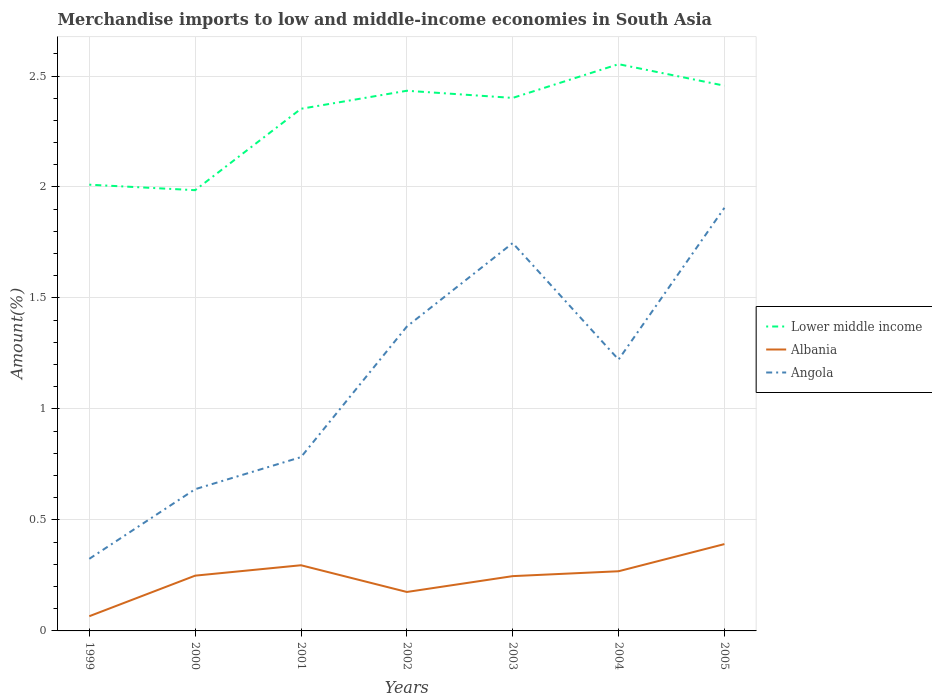Is the number of lines equal to the number of legend labels?
Offer a very short reply. Yes. Across all years, what is the maximum percentage of amount earned from merchandise imports in Angola?
Keep it short and to the point. 0.32. In which year was the percentage of amount earned from merchandise imports in Albania maximum?
Make the answer very short. 1999. What is the total percentage of amount earned from merchandise imports in Lower middle income in the graph?
Offer a terse response. -0.34. What is the difference between the highest and the second highest percentage of amount earned from merchandise imports in Albania?
Give a very brief answer. 0.32. How many lines are there?
Your response must be concise. 3. How many years are there in the graph?
Provide a short and direct response. 7. What is the difference between two consecutive major ticks on the Y-axis?
Your answer should be compact. 0.5. Are the values on the major ticks of Y-axis written in scientific E-notation?
Your answer should be compact. No. Does the graph contain any zero values?
Your answer should be very brief. No. How are the legend labels stacked?
Provide a short and direct response. Vertical. What is the title of the graph?
Your response must be concise. Merchandise imports to low and middle-income economies in South Asia. Does "Belarus" appear as one of the legend labels in the graph?
Make the answer very short. No. What is the label or title of the X-axis?
Offer a very short reply. Years. What is the label or title of the Y-axis?
Your answer should be very brief. Amount(%). What is the Amount(%) of Lower middle income in 1999?
Give a very brief answer. 2.01. What is the Amount(%) of Albania in 1999?
Make the answer very short. 0.07. What is the Amount(%) of Angola in 1999?
Provide a succinct answer. 0.32. What is the Amount(%) of Lower middle income in 2000?
Your answer should be very brief. 1.99. What is the Amount(%) of Albania in 2000?
Offer a very short reply. 0.25. What is the Amount(%) of Angola in 2000?
Make the answer very short. 0.64. What is the Amount(%) of Lower middle income in 2001?
Your answer should be very brief. 2.35. What is the Amount(%) of Albania in 2001?
Offer a very short reply. 0.3. What is the Amount(%) in Angola in 2001?
Keep it short and to the point. 0.78. What is the Amount(%) in Lower middle income in 2002?
Offer a terse response. 2.43. What is the Amount(%) in Albania in 2002?
Provide a short and direct response. 0.18. What is the Amount(%) of Angola in 2002?
Your response must be concise. 1.37. What is the Amount(%) in Lower middle income in 2003?
Provide a short and direct response. 2.4. What is the Amount(%) of Albania in 2003?
Offer a terse response. 0.25. What is the Amount(%) of Angola in 2003?
Offer a very short reply. 1.75. What is the Amount(%) in Lower middle income in 2004?
Provide a succinct answer. 2.55. What is the Amount(%) of Albania in 2004?
Offer a very short reply. 0.27. What is the Amount(%) of Angola in 2004?
Offer a terse response. 1.22. What is the Amount(%) of Lower middle income in 2005?
Keep it short and to the point. 2.46. What is the Amount(%) of Albania in 2005?
Offer a terse response. 0.39. What is the Amount(%) of Angola in 2005?
Offer a very short reply. 1.91. Across all years, what is the maximum Amount(%) in Lower middle income?
Provide a succinct answer. 2.55. Across all years, what is the maximum Amount(%) in Albania?
Provide a short and direct response. 0.39. Across all years, what is the maximum Amount(%) in Angola?
Keep it short and to the point. 1.91. Across all years, what is the minimum Amount(%) of Lower middle income?
Your response must be concise. 1.99. Across all years, what is the minimum Amount(%) in Albania?
Give a very brief answer. 0.07. Across all years, what is the minimum Amount(%) in Angola?
Keep it short and to the point. 0.32. What is the total Amount(%) in Lower middle income in the graph?
Keep it short and to the point. 16.19. What is the total Amount(%) in Albania in the graph?
Offer a very short reply. 1.69. What is the total Amount(%) in Angola in the graph?
Provide a short and direct response. 7.99. What is the difference between the Amount(%) of Lower middle income in 1999 and that in 2000?
Your answer should be compact. 0.02. What is the difference between the Amount(%) of Albania in 1999 and that in 2000?
Offer a very short reply. -0.18. What is the difference between the Amount(%) in Angola in 1999 and that in 2000?
Your response must be concise. -0.31. What is the difference between the Amount(%) of Lower middle income in 1999 and that in 2001?
Provide a succinct answer. -0.34. What is the difference between the Amount(%) of Albania in 1999 and that in 2001?
Make the answer very short. -0.23. What is the difference between the Amount(%) in Angola in 1999 and that in 2001?
Provide a short and direct response. -0.46. What is the difference between the Amount(%) of Lower middle income in 1999 and that in 2002?
Give a very brief answer. -0.42. What is the difference between the Amount(%) of Albania in 1999 and that in 2002?
Your answer should be compact. -0.11. What is the difference between the Amount(%) of Angola in 1999 and that in 2002?
Your response must be concise. -1.05. What is the difference between the Amount(%) of Lower middle income in 1999 and that in 2003?
Make the answer very short. -0.39. What is the difference between the Amount(%) in Albania in 1999 and that in 2003?
Offer a very short reply. -0.18. What is the difference between the Amount(%) in Angola in 1999 and that in 2003?
Ensure brevity in your answer.  -1.42. What is the difference between the Amount(%) of Lower middle income in 1999 and that in 2004?
Make the answer very short. -0.54. What is the difference between the Amount(%) in Albania in 1999 and that in 2004?
Make the answer very short. -0.2. What is the difference between the Amount(%) in Angola in 1999 and that in 2004?
Your answer should be very brief. -0.9. What is the difference between the Amount(%) of Lower middle income in 1999 and that in 2005?
Keep it short and to the point. -0.45. What is the difference between the Amount(%) of Albania in 1999 and that in 2005?
Give a very brief answer. -0.33. What is the difference between the Amount(%) of Angola in 1999 and that in 2005?
Offer a very short reply. -1.58. What is the difference between the Amount(%) in Lower middle income in 2000 and that in 2001?
Offer a terse response. -0.37. What is the difference between the Amount(%) of Albania in 2000 and that in 2001?
Make the answer very short. -0.05. What is the difference between the Amount(%) in Angola in 2000 and that in 2001?
Make the answer very short. -0.14. What is the difference between the Amount(%) in Lower middle income in 2000 and that in 2002?
Ensure brevity in your answer.  -0.45. What is the difference between the Amount(%) of Albania in 2000 and that in 2002?
Offer a terse response. 0.07. What is the difference between the Amount(%) of Angola in 2000 and that in 2002?
Keep it short and to the point. -0.73. What is the difference between the Amount(%) of Lower middle income in 2000 and that in 2003?
Ensure brevity in your answer.  -0.42. What is the difference between the Amount(%) of Albania in 2000 and that in 2003?
Your response must be concise. 0. What is the difference between the Amount(%) of Angola in 2000 and that in 2003?
Your response must be concise. -1.11. What is the difference between the Amount(%) in Lower middle income in 2000 and that in 2004?
Provide a succinct answer. -0.57. What is the difference between the Amount(%) of Albania in 2000 and that in 2004?
Give a very brief answer. -0.02. What is the difference between the Amount(%) in Angola in 2000 and that in 2004?
Offer a very short reply. -0.58. What is the difference between the Amount(%) in Lower middle income in 2000 and that in 2005?
Offer a very short reply. -0.47. What is the difference between the Amount(%) of Albania in 2000 and that in 2005?
Provide a short and direct response. -0.14. What is the difference between the Amount(%) of Angola in 2000 and that in 2005?
Ensure brevity in your answer.  -1.27. What is the difference between the Amount(%) in Lower middle income in 2001 and that in 2002?
Your response must be concise. -0.08. What is the difference between the Amount(%) of Albania in 2001 and that in 2002?
Give a very brief answer. 0.12. What is the difference between the Amount(%) of Angola in 2001 and that in 2002?
Provide a short and direct response. -0.59. What is the difference between the Amount(%) in Lower middle income in 2001 and that in 2003?
Offer a very short reply. -0.05. What is the difference between the Amount(%) in Albania in 2001 and that in 2003?
Your answer should be compact. 0.05. What is the difference between the Amount(%) in Angola in 2001 and that in 2003?
Keep it short and to the point. -0.96. What is the difference between the Amount(%) of Lower middle income in 2001 and that in 2004?
Your answer should be very brief. -0.2. What is the difference between the Amount(%) of Albania in 2001 and that in 2004?
Offer a very short reply. 0.03. What is the difference between the Amount(%) in Angola in 2001 and that in 2004?
Ensure brevity in your answer.  -0.44. What is the difference between the Amount(%) in Lower middle income in 2001 and that in 2005?
Give a very brief answer. -0.1. What is the difference between the Amount(%) of Albania in 2001 and that in 2005?
Your answer should be compact. -0.1. What is the difference between the Amount(%) of Angola in 2001 and that in 2005?
Your answer should be very brief. -1.12. What is the difference between the Amount(%) in Lower middle income in 2002 and that in 2003?
Your answer should be compact. 0.03. What is the difference between the Amount(%) of Albania in 2002 and that in 2003?
Provide a succinct answer. -0.07. What is the difference between the Amount(%) of Angola in 2002 and that in 2003?
Offer a very short reply. -0.38. What is the difference between the Amount(%) in Lower middle income in 2002 and that in 2004?
Your answer should be very brief. -0.12. What is the difference between the Amount(%) in Albania in 2002 and that in 2004?
Your answer should be compact. -0.09. What is the difference between the Amount(%) in Angola in 2002 and that in 2004?
Provide a short and direct response. 0.15. What is the difference between the Amount(%) in Lower middle income in 2002 and that in 2005?
Your answer should be compact. -0.02. What is the difference between the Amount(%) in Albania in 2002 and that in 2005?
Keep it short and to the point. -0.22. What is the difference between the Amount(%) in Angola in 2002 and that in 2005?
Give a very brief answer. -0.53. What is the difference between the Amount(%) of Lower middle income in 2003 and that in 2004?
Provide a short and direct response. -0.15. What is the difference between the Amount(%) in Albania in 2003 and that in 2004?
Offer a very short reply. -0.02. What is the difference between the Amount(%) of Angola in 2003 and that in 2004?
Make the answer very short. 0.52. What is the difference between the Amount(%) of Lower middle income in 2003 and that in 2005?
Ensure brevity in your answer.  -0.06. What is the difference between the Amount(%) in Albania in 2003 and that in 2005?
Keep it short and to the point. -0.14. What is the difference between the Amount(%) of Angola in 2003 and that in 2005?
Your answer should be very brief. -0.16. What is the difference between the Amount(%) in Lower middle income in 2004 and that in 2005?
Ensure brevity in your answer.  0.1. What is the difference between the Amount(%) in Albania in 2004 and that in 2005?
Provide a succinct answer. -0.12. What is the difference between the Amount(%) in Angola in 2004 and that in 2005?
Ensure brevity in your answer.  -0.68. What is the difference between the Amount(%) in Lower middle income in 1999 and the Amount(%) in Albania in 2000?
Give a very brief answer. 1.76. What is the difference between the Amount(%) of Lower middle income in 1999 and the Amount(%) of Angola in 2000?
Make the answer very short. 1.37. What is the difference between the Amount(%) of Albania in 1999 and the Amount(%) of Angola in 2000?
Your answer should be compact. -0.57. What is the difference between the Amount(%) in Lower middle income in 1999 and the Amount(%) in Albania in 2001?
Ensure brevity in your answer.  1.71. What is the difference between the Amount(%) in Lower middle income in 1999 and the Amount(%) in Angola in 2001?
Make the answer very short. 1.23. What is the difference between the Amount(%) of Albania in 1999 and the Amount(%) of Angola in 2001?
Offer a terse response. -0.72. What is the difference between the Amount(%) of Lower middle income in 1999 and the Amount(%) of Albania in 2002?
Give a very brief answer. 1.83. What is the difference between the Amount(%) of Lower middle income in 1999 and the Amount(%) of Angola in 2002?
Offer a terse response. 0.64. What is the difference between the Amount(%) in Albania in 1999 and the Amount(%) in Angola in 2002?
Give a very brief answer. -1.31. What is the difference between the Amount(%) in Lower middle income in 1999 and the Amount(%) in Albania in 2003?
Keep it short and to the point. 1.76. What is the difference between the Amount(%) in Lower middle income in 1999 and the Amount(%) in Angola in 2003?
Keep it short and to the point. 0.26. What is the difference between the Amount(%) in Albania in 1999 and the Amount(%) in Angola in 2003?
Offer a terse response. -1.68. What is the difference between the Amount(%) of Lower middle income in 1999 and the Amount(%) of Albania in 2004?
Offer a very short reply. 1.74. What is the difference between the Amount(%) of Lower middle income in 1999 and the Amount(%) of Angola in 2004?
Ensure brevity in your answer.  0.79. What is the difference between the Amount(%) of Albania in 1999 and the Amount(%) of Angola in 2004?
Your response must be concise. -1.16. What is the difference between the Amount(%) of Lower middle income in 1999 and the Amount(%) of Albania in 2005?
Offer a terse response. 1.62. What is the difference between the Amount(%) in Lower middle income in 1999 and the Amount(%) in Angola in 2005?
Your answer should be compact. 0.1. What is the difference between the Amount(%) in Albania in 1999 and the Amount(%) in Angola in 2005?
Ensure brevity in your answer.  -1.84. What is the difference between the Amount(%) in Lower middle income in 2000 and the Amount(%) in Albania in 2001?
Ensure brevity in your answer.  1.69. What is the difference between the Amount(%) in Lower middle income in 2000 and the Amount(%) in Angola in 2001?
Provide a short and direct response. 1.2. What is the difference between the Amount(%) in Albania in 2000 and the Amount(%) in Angola in 2001?
Your answer should be very brief. -0.53. What is the difference between the Amount(%) of Lower middle income in 2000 and the Amount(%) of Albania in 2002?
Your answer should be compact. 1.81. What is the difference between the Amount(%) of Lower middle income in 2000 and the Amount(%) of Angola in 2002?
Ensure brevity in your answer.  0.61. What is the difference between the Amount(%) of Albania in 2000 and the Amount(%) of Angola in 2002?
Your response must be concise. -1.12. What is the difference between the Amount(%) in Lower middle income in 2000 and the Amount(%) in Albania in 2003?
Ensure brevity in your answer.  1.74. What is the difference between the Amount(%) in Lower middle income in 2000 and the Amount(%) in Angola in 2003?
Your response must be concise. 0.24. What is the difference between the Amount(%) of Albania in 2000 and the Amount(%) of Angola in 2003?
Provide a short and direct response. -1.5. What is the difference between the Amount(%) of Lower middle income in 2000 and the Amount(%) of Albania in 2004?
Your answer should be very brief. 1.72. What is the difference between the Amount(%) in Lower middle income in 2000 and the Amount(%) in Angola in 2004?
Your response must be concise. 0.76. What is the difference between the Amount(%) of Albania in 2000 and the Amount(%) of Angola in 2004?
Ensure brevity in your answer.  -0.97. What is the difference between the Amount(%) in Lower middle income in 2000 and the Amount(%) in Albania in 2005?
Offer a terse response. 1.59. What is the difference between the Amount(%) in Lower middle income in 2000 and the Amount(%) in Angola in 2005?
Your response must be concise. 0.08. What is the difference between the Amount(%) in Albania in 2000 and the Amount(%) in Angola in 2005?
Keep it short and to the point. -1.66. What is the difference between the Amount(%) of Lower middle income in 2001 and the Amount(%) of Albania in 2002?
Offer a very short reply. 2.18. What is the difference between the Amount(%) in Lower middle income in 2001 and the Amount(%) in Angola in 2002?
Keep it short and to the point. 0.98. What is the difference between the Amount(%) in Albania in 2001 and the Amount(%) in Angola in 2002?
Ensure brevity in your answer.  -1.08. What is the difference between the Amount(%) of Lower middle income in 2001 and the Amount(%) of Albania in 2003?
Make the answer very short. 2.11. What is the difference between the Amount(%) of Lower middle income in 2001 and the Amount(%) of Angola in 2003?
Your response must be concise. 0.6. What is the difference between the Amount(%) of Albania in 2001 and the Amount(%) of Angola in 2003?
Provide a short and direct response. -1.45. What is the difference between the Amount(%) in Lower middle income in 2001 and the Amount(%) in Albania in 2004?
Keep it short and to the point. 2.08. What is the difference between the Amount(%) in Lower middle income in 2001 and the Amount(%) in Angola in 2004?
Keep it short and to the point. 1.13. What is the difference between the Amount(%) in Albania in 2001 and the Amount(%) in Angola in 2004?
Ensure brevity in your answer.  -0.93. What is the difference between the Amount(%) in Lower middle income in 2001 and the Amount(%) in Albania in 2005?
Offer a very short reply. 1.96. What is the difference between the Amount(%) in Lower middle income in 2001 and the Amount(%) in Angola in 2005?
Provide a succinct answer. 0.45. What is the difference between the Amount(%) of Albania in 2001 and the Amount(%) of Angola in 2005?
Make the answer very short. -1.61. What is the difference between the Amount(%) in Lower middle income in 2002 and the Amount(%) in Albania in 2003?
Ensure brevity in your answer.  2.19. What is the difference between the Amount(%) of Lower middle income in 2002 and the Amount(%) of Angola in 2003?
Provide a succinct answer. 0.69. What is the difference between the Amount(%) in Albania in 2002 and the Amount(%) in Angola in 2003?
Ensure brevity in your answer.  -1.57. What is the difference between the Amount(%) of Lower middle income in 2002 and the Amount(%) of Albania in 2004?
Your answer should be very brief. 2.16. What is the difference between the Amount(%) of Lower middle income in 2002 and the Amount(%) of Angola in 2004?
Keep it short and to the point. 1.21. What is the difference between the Amount(%) of Albania in 2002 and the Amount(%) of Angola in 2004?
Offer a very short reply. -1.05. What is the difference between the Amount(%) of Lower middle income in 2002 and the Amount(%) of Albania in 2005?
Make the answer very short. 2.04. What is the difference between the Amount(%) in Lower middle income in 2002 and the Amount(%) in Angola in 2005?
Keep it short and to the point. 0.53. What is the difference between the Amount(%) in Albania in 2002 and the Amount(%) in Angola in 2005?
Your response must be concise. -1.73. What is the difference between the Amount(%) of Lower middle income in 2003 and the Amount(%) of Albania in 2004?
Provide a succinct answer. 2.13. What is the difference between the Amount(%) in Lower middle income in 2003 and the Amount(%) in Angola in 2004?
Your answer should be compact. 1.18. What is the difference between the Amount(%) in Albania in 2003 and the Amount(%) in Angola in 2004?
Offer a terse response. -0.98. What is the difference between the Amount(%) in Lower middle income in 2003 and the Amount(%) in Albania in 2005?
Offer a very short reply. 2.01. What is the difference between the Amount(%) of Lower middle income in 2003 and the Amount(%) of Angola in 2005?
Offer a terse response. 0.5. What is the difference between the Amount(%) of Albania in 2003 and the Amount(%) of Angola in 2005?
Your answer should be compact. -1.66. What is the difference between the Amount(%) in Lower middle income in 2004 and the Amount(%) in Albania in 2005?
Give a very brief answer. 2.16. What is the difference between the Amount(%) in Lower middle income in 2004 and the Amount(%) in Angola in 2005?
Provide a short and direct response. 0.65. What is the difference between the Amount(%) in Albania in 2004 and the Amount(%) in Angola in 2005?
Offer a very short reply. -1.64. What is the average Amount(%) of Lower middle income per year?
Offer a very short reply. 2.31. What is the average Amount(%) in Albania per year?
Your answer should be very brief. 0.24. What is the average Amount(%) in Angola per year?
Give a very brief answer. 1.14. In the year 1999, what is the difference between the Amount(%) in Lower middle income and Amount(%) in Albania?
Offer a terse response. 1.94. In the year 1999, what is the difference between the Amount(%) in Lower middle income and Amount(%) in Angola?
Give a very brief answer. 1.69. In the year 1999, what is the difference between the Amount(%) in Albania and Amount(%) in Angola?
Offer a very short reply. -0.26. In the year 2000, what is the difference between the Amount(%) in Lower middle income and Amount(%) in Albania?
Offer a terse response. 1.74. In the year 2000, what is the difference between the Amount(%) in Lower middle income and Amount(%) in Angola?
Provide a short and direct response. 1.35. In the year 2000, what is the difference between the Amount(%) of Albania and Amount(%) of Angola?
Your response must be concise. -0.39. In the year 2001, what is the difference between the Amount(%) of Lower middle income and Amount(%) of Albania?
Your answer should be compact. 2.06. In the year 2001, what is the difference between the Amount(%) of Lower middle income and Amount(%) of Angola?
Keep it short and to the point. 1.57. In the year 2001, what is the difference between the Amount(%) in Albania and Amount(%) in Angola?
Give a very brief answer. -0.49. In the year 2002, what is the difference between the Amount(%) in Lower middle income and Amount(%) in Albania?
Keep it short and to the point. 2.26. In the year 2002, what is the difference between the Amount(%) of Lower middle income and Amount(%) of Angola?
Provide a short and direct response. 1.06. In the year 2002, what is the difference between the Amount(%) of Albania and Amount(%) of Angola?
Your answer should be very brief. -1.2. In the year 2003, what is the difference between the Amount(%) of Lower middle income and Amount(%) of Albania?
Provide a short and direct response. 2.15. In the year 2003, what is the difference between the Amount(%) of Lower middle income and Amount(%) of Angola?
Your response must be concise. 0.65. In the year 2003, what is the difference between the Amount(%) in Albania and Amount(%) in Angola?
Your answer should be very brief. -1.5. In the year 2004, what is the difference between the Amount(%) of Lower middle income and Amount(%) of Albania?
Provide a succinct answer. 2.28. In the year 2004, what is the difference between the Amount(%) of Lower middle income and Amount(%) of Angola?
Offer a terse response. 1.33. In the year 2004, what is the difference between the Amount(%) of Albania and Amount(%) of Angola?
Offer a very short reply. -0.95. In the year 2005, what is the difference between the Amount(%) of Lower middle income and Amount(%) of Albania?
Your answer should be compact. 2.07. In the year 2005, what is the difference between the Amount(%) in Lower middle income and Amount(%) in Angola?
Your answer should be compact. 0.55. In the year 2005, what is the difference between the Amount(%) in Albania and Amount(%) in Angola?
Offer a terse response. -1.51. What is the ratio of the Amount(%) of Lower middle income in 1999 to that in 2000?
Provide a succinct answer. 1.01. What is the ratio of the Amount(%) in Albania in 1999 to that in 2000?
Your answer should be compact. 0.27. What is the ratio of the Amount(%) of Angola in 1999 to that in 2000?
Your answer should be compact. 0.51. What is the ratio of the Amount(%) in Lower middle income in 1999 to that in 2001?
Your answer should be compact. 0.85. What is the ratio of the Amount(%) in Albania in 1999 to that in 2001?
Your answer should be compact. 0.22. What is the ratio of the Amount(%) in Angola in 1999 to that in 2001?
Provide a short and direct response. 0.41. What is the ratio of the Amount(%) of Lower middle income in 1999 to that in 2002?
Give a very brief answer. 0.83. What is the ratio of the Amount(%) in Albania in 1999 to that in 2002?
Your response must be concise. 0.38. What is the ratio of the Amount(%) of Angola in 1999 to that in 2002?
Provide a succinct answer. 0.24. What is the ratio of the Amount(%) in Lower middle income in 1999 to that in 2003?
Ensure brevity in your answer.  0.84. What is the ratio of the Amount(%) of Albania in 1999 to that in 2003?
Your answer should be very brief. 0.27. What is the ratio of the Amount(%) in Angola in 1999 to that in 2003?
Provide a succinct answer. 0.19. What is the ratio of the Amount(%) of Lower middle income in 1999 to that in 2004?
Give a very brief answer. 0.79. What is the ratio of the Amount(%) in Albania in 1999 to that in 2004?
Give a very brief answer. 0.25. What is the ratio of the Amount(%) in Angola in 1999 to that in 2004?
Offer a very short reply. 0.27. What is the ratio of the Amount(%) of Lower middle income in 1999 to that in 2005?
Provide a succinct answer. 0.82. What is the ratio of the Amount(%) in Albania in 1999 to that in 2005?
Offer a very short reply. 0.17. What is the ratio of the Amount(%) of Angola in 1999 to that in 2005?
Offer a terse response. 0.17. What is the ratio of the Amount(%) in Lower middle income in 2000 to that in 2001?
Ensure brevity in your answer.  0.84. What is the ratio of the Amount(%) of Albania in 2000 to that in 2001?
Offer a very short reply. 0.84. What is the ratio of the Amount(%) of Angola in 2000 to that in 2001?
Provide a short and direct response. 0.82. What is the ratio of the Amount(%) in Lower middle income in 2000 to that in 2002?
Offer a terse response. 0.82. What is the ratio of the Amount(%) of Albania in 2000 to that in 2002?
Your answer should be compact. 1.42. What is the ratio of the Amount(%) in Angola in 2000 to that in 2002?
Your answer should be compact. 0.47. What is the ratio of the Amount(%) of Lower middle income in 2000 to that in 2003?
Your response must be concise. 0.83. What is the ratio of the Amount(%) in Albania in 2000 to that in 2003?
Provide a short and direct response. 1.01. What is the ratio of the Amount(%) in Angola in 2000 to that in 2003?
Your response must be concise. 0.37. What is the ratio of the Amount(%) in Lower middle income in 2000 to that in 2004?
Make the answer very short. 0.78. What is the ratio of the Amount(%) in Albania in 2000 to that in 2004?
Provide a short and direct response. 0.93. What is the ratio of the Amount(%) of Angola in 2000 to that in 2004?
Your response must be concise. 0.52. What is the ratio of the Amount(%) of Lower middle income in 2000 to that in 2005?
Provide a short and direct response. 0.81. What is the ratio of the Amount(%) in Albania in 2000 to that in 2005?
Offer a very short reply. 0.64. What is the ratio of the Amount(%) in Angola in 2000 to that in 2005?
Your answer should be compact. 0.34. What is the ratio of the Amount(%) of Lower middle income in 2001 to that in 2002?
Your answer should be very brief. 0.97. What is the ratio of the Amount(%) in Albania in 2001 to that in 2002?
Your response must be concise. 1.69. What is the ratio of the Amount(%) in Angola in 2001 to that in 2002?
Your answer should be very brief. 0.57. What is the ratio of the Amount(%) of Lower middle income in 2001 to that in 2003?
Offer a very short reply. 0.98. What is the ratio of the Amount(%) of Albania in 2001 to that in 2003?
Your answer should be very brief. 1.2. What is the ratio of the Amount(%) in Angola in 2001 to that in 2003?
Keep it short and to the point. 0.45. What is the ratio of the Amount(%) in Lower middle income in 2001 to that in 2004?
Offer a terse response. 0.92. What is the ratio of the Amount(%) in Albania in 2001 to that in 2004?
Your response must be concise. 1.1. What is the ratio of the Amount(%) of Angola in 2001 to that in 2004?
Your answer should be very brief. 0.64. What is the ratio of the Amount(%) in Lower middle income in 2001 to that in 2005?
Your response must be concise. 0.96. What is the ratio of the Amount(%) in Albania in 2001 to that in 2005?
Make the answer very short. 0.76. What is the ratio of the Amount(%) in Angola in 2001 to that in 2005?
Ensure brevity in your answer.  0.41. What is the ratio of the Amount(%) of Lower middle income in 2002 to that in 2003?
Provide a succinct answer. 1.01. What is the ratio of the Amount(%) in Albania in 2002 to that in 2003?
Make the answer very short. 0.71. What is the ratio of the Amount(%) in Angola in 2002 to that in 2003?
Your answer should be compact. 0.78. What is the ratio of the Amount(%) of Lower middle income in 2002 to that in 2004?
Keep it short and to the point. 0.95. What is the ratio of the Amount(%) of Albania in 2002 to that in 2004?
Give a very brief answer. 0.65. What is the ratio of the Amount(%) in Angola in 2002 to that in 2004?
Your response must be concise. 1.12. What is the ratio of the Amount(%) in Albania in 2002 to that in 2005?
Provide a succinct answer. 0.45. What is the ratio of the Amount(%) of Angola in 2002 to that in 2005?
Provide a succinct answer. 0.72. What is the ratio of the Amount(%) in Lower middle income in 2003 to that in 2004?
Your answer should be very brief. 0.94. What is the ratio of the Amount(%) of Albania in 2003 to that in 2004?
Your answer should be very brief. 0.92. What is the ratio of the Amount(%) in Angola in 2003 to that in 2004?
Provide a short and direct response. 1.43. What is the ratio of the Amount(%) of Lower middle income in 2003 to that in 2005?
Offer a very short reply. 0.98. What is the ratio of the Amount(%) of Albania in 2003 to that in 2005?
Give a very brief answer. 0.63. What is the ratio of the Amount(%) in Lower middle income in 2004 to that in 2005?
Give a very brief answer. 1.04. What is the ratio of the Amount(%) in Albania in 2004 to that in 2005?
Provide a succinct answer. 0.69. What is the ratio of the Amount(%) of Angola in 2004 to that in 2005?
Make the answer very short. 0.64. What is the difference between the highest and the second highest Amount(%) of Lower middle income?
Your answer should be very brief. 0.1. What is the difference between the highest and the second highest Amount(%) of Albania?
Give a very brief answer. 0.1. What is the difference between the highest and the second highest Amount(%) in Angola?
Give a very brief answer. 0.16. What is the difference between the highest and the lowest Amount(%) in Lower middle income?
Offer a very short reply. 0.57. What is the difference between the highest and the lowest Amount(%) in Albania?
Give a very brief answer. 0.33. What is the difference between the highest and the lowest Amount(%) of Angola?
Provide a short and direct response. 1.58. 